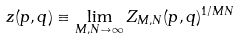Convert formula to latex. <formula><loc_0><loc_0><loc_500><loc_500>z ( p , q ) \equiv \lim _ { M , N \to \infty } Z _ { M , N } ( p , q ) ^ { 1 / M N }</formula> 